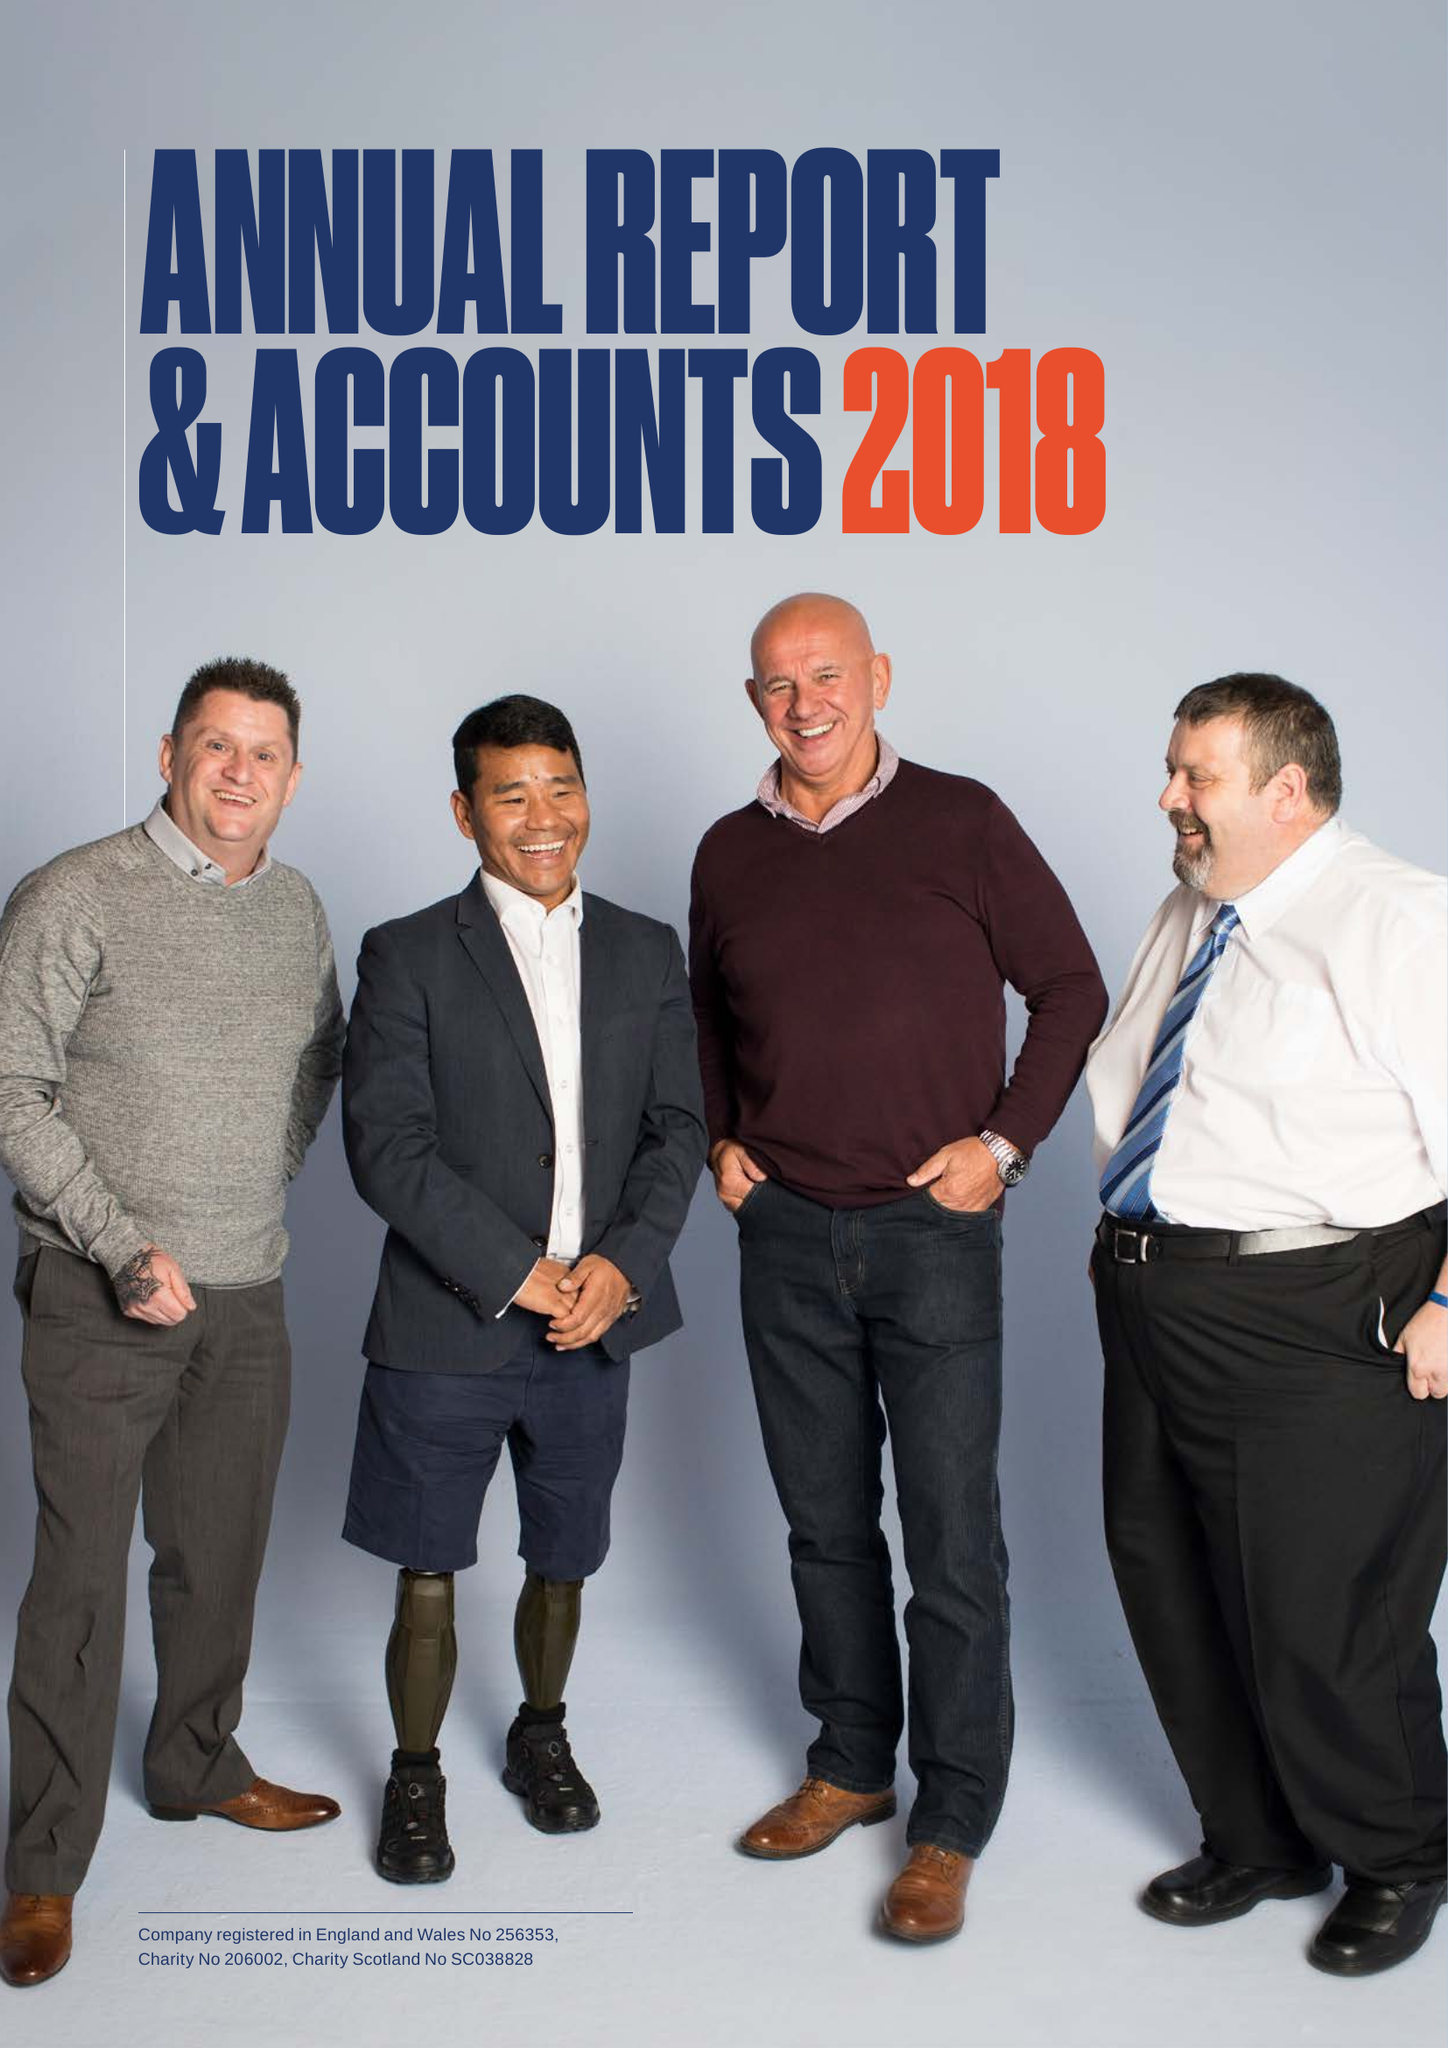What is the value for the address__street_line?
Answer the question using a single word or phrase. OAKLAWN ROAD 